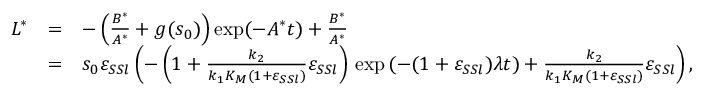<formula> <loc_0><loc_0><loc_500><loc_500>\begin{array} { r c l } { L ^ { * } } & { = } & { - \left ( \frac { B ^ { * } } { A ^ { * } } + g ( s _ { 0 } ) \right ) \exp ( - A ^ { * } t ) + \frac { B ^ { * } } { A ^ { * } } } \\ & { = } & { s _ { 0 } \varepsilon _ { S S l } \left ( - \left ( 1 + \frac { k _ { 2 } } { k _ { 1 } K _ { M } ( 1 + \varepsilon _ { S S l } ) } \varepsilon _ { S S l } \right ) \, \exp { ( - ( 1 + \varepsilon _ { S S l } ) \lambda t ) } + \frac { k _ { 2 } } { k _ { 1 } K _ { M } ( 1 + \varepsilon _ { S S l } ) } \varepsilon _ { S S l } \right ) , } \end{array}</formula> 